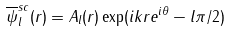<formula> <loc_0><loc_0><loc_500><loc_500>\overline { \psi } _ { l } ^ { s c } ( r ) = A _ { l } ( r ) \exp ( i k r e ^ { i \theta } - l \pi / 2 )</formula> 